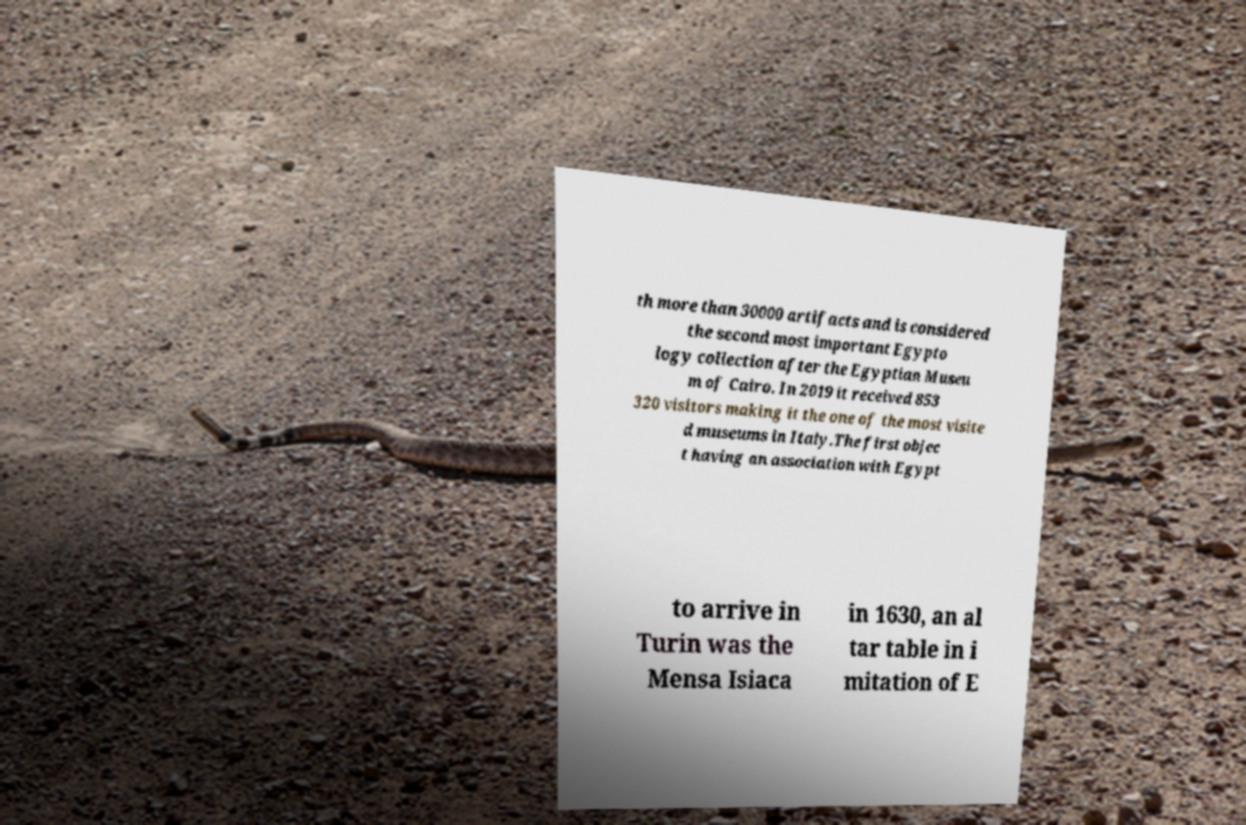Can you accurately transcribe the text from the provided image for me? th more than 30000 artifacts and is considered the second most important Egypto logy collection after the Egyptian Museu m of Cairo. In 2019 it received 853 320 visitors making it the one of the most visite d museums in Italy.The first objec t having an association with Egypt to arrive in Turin was the Mensa Isiaca in 1630, an al tar table in i mitation of E 